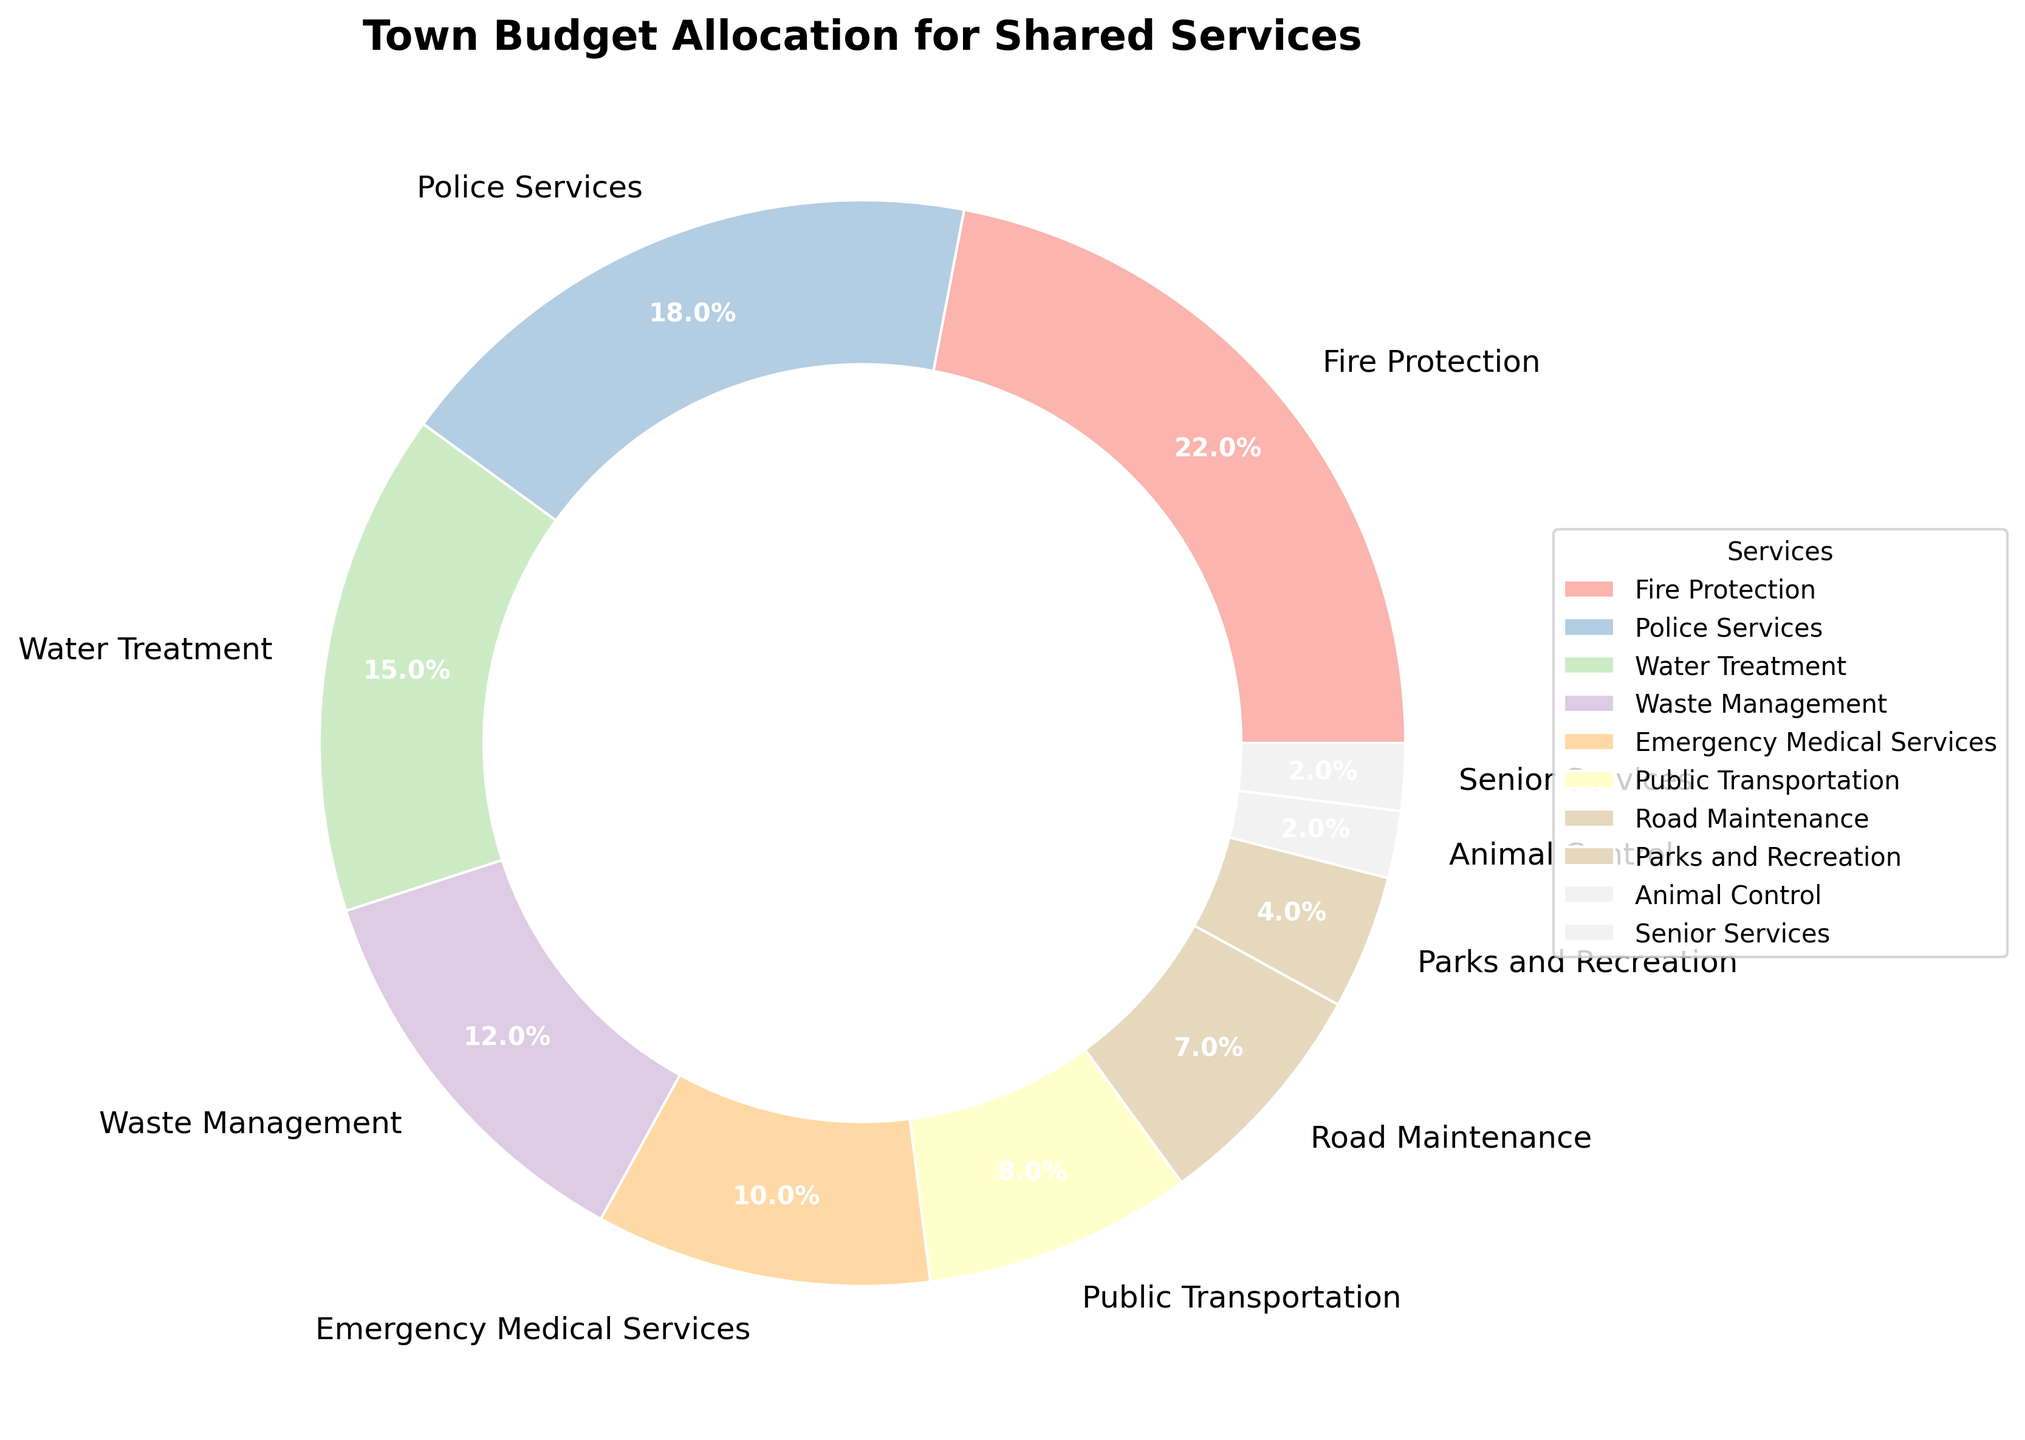Which service has the largest budget allocation? The service with the largest budget allocation can be identified by finding the segment with the largest percentage. The largest segment is Fire Protection, which accounts for 22% of the budget.
Answer: Fire Protection What percentage of the budget is allocated to both Emergency Medical Services and Public Transportation combined? To find the combined percentage, add the percentages allocated to Emergency Medical Services (10%) and Public Transportation (8%): 10% + 8% = 18%.
Answer: 18% Which service gets a smaller budget allocation: Water Treatment or Waste Management? Compare the percentages of Water Treatment (15%) and Waste Management (12%). Waste Management has a smaller budget allocation.
Answer: Waste Management What is the total percentage of the budget allocated to services with less than 5% allocation each? Identify the services with less than 5% each: Parks and Recreation (4%), Animal Control (2%), and Senior Services (2%). Sum these percentages: 4% + 2% + 2% = 8%.
Answer: 8% Which service has the smallest budget allocation? The service with the smallest segment in the pie chart represents the smallest budget allocation. The smallest segment is for Animal Control and Senior Services, each with 2%.
Answer: Animal Control or Senior Services How much more percentage allocation does Fire Protection have compared to Police Services? Find the difference in percentage between Fire Protection (22%) and Police Services (18%): 22% - 18% = 4%.
Answer: 4% What is the average percentage allocation for Fire Protection, Police Services, and Water Treatment? Calculate the average by summing the allocations and dividing by the number of services: (22% + 18% + 15%) / 3 = 55% / 3 ≈ 18.33%.
Answer: 18.33% Which category has a higher budget allocation: Emergency Medical Services or Road Maintenance? Compare the percentages of Emergency Medical Services (10%) and Road Maintenance (7%). Emergency Medical Services has a higher budget allocation.
Answer: Emergency Medical Services How many services have a budget allocation less than or equal to 10%? Count the services with budget allocations of 10% or less: Waste Management (12%), Emergency Medical Services (10%), Public Transportation (8%), Road Maintenance (7%), Parks and Recreation (4%), Animal Control (2%), Senior Services (2%). Total: 6 services.
Answer: 6 If the total budget is $1,000,000, how much is allocated to Water Treatment? Calculate the amount by applying the percentage allocation to the total budget: 15% of $1,000,000 = 0.15 * $1,000,000 = $150,000.
Answer: $150,000 